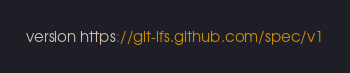Convert code to text. <code><loc_0><loc_0><loc_500><loc_500><_JavaScript_>version https://git-lfs.github.com/spec/v1</code> 